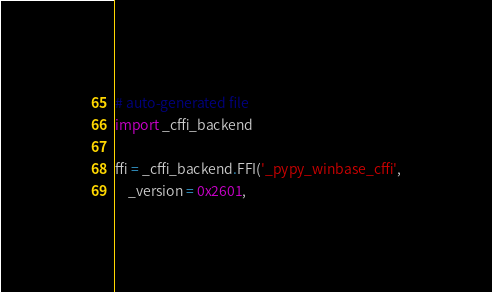<code> <loc_0><loc_0><loc_500><loc_500><_Python_># auto-generated file
import _cffi_backend

ffi = _cffi_backend.FFI('_pypy_winbase_cffi',
    _version = 0x2601,</code> 